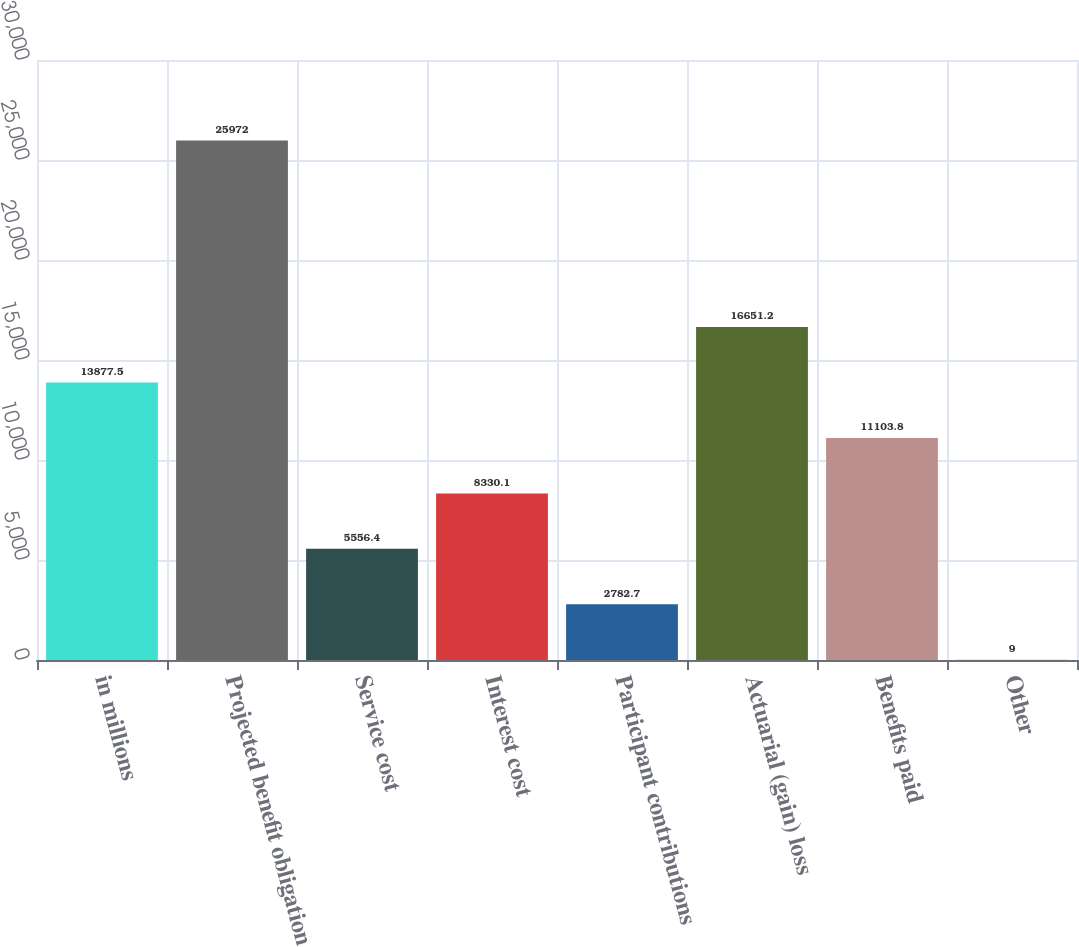<chart> <loc_0><loc_0><loc_500><loc_500><bar_chart><fcel>in millions<fcel>Projected benefit obligation<fcel>Service cost<fcel>Interest cost<fcel>Participant contributions<fcel>Actuarial (gain) loss<fcel>Benefits paid<fcel>Other<nl><fcel>13877.5<fcel>25972<fcel>5556.4<fcel>8330.1<fcel>2782.7<fcel>16651.2<fcel>11103.8<fcel>9<nl></chart> 